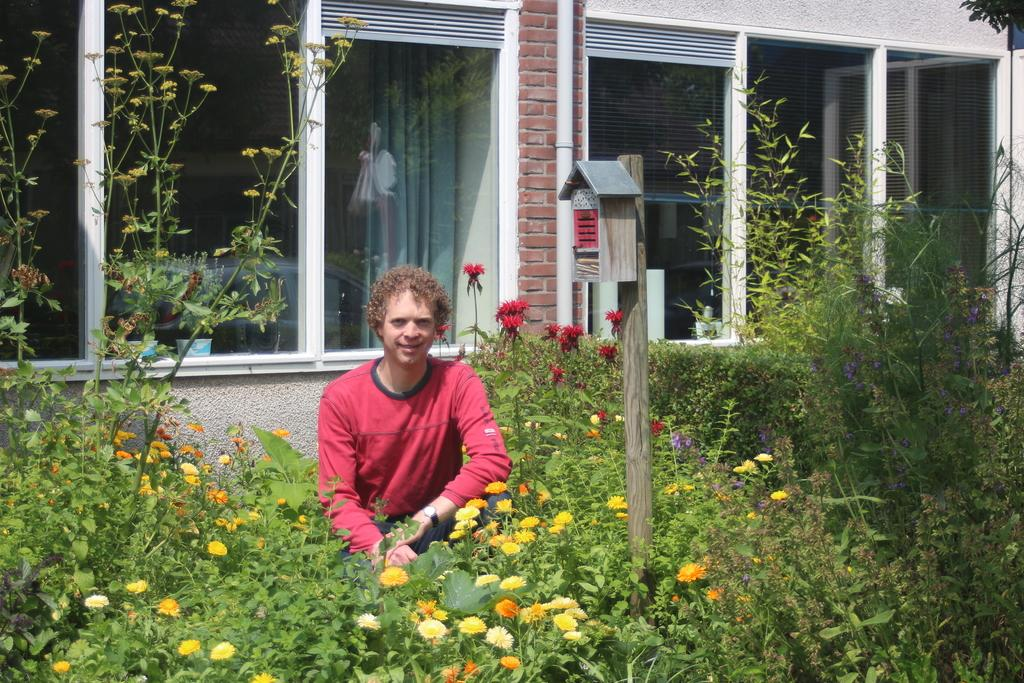What is the person in the image doing? There is a person smiling in the image. What type of vegetation can be seen in the image? There are plants and flowers in the image. Can you describe the structure in the image? There is a box on a wooden pole in the image. What can be seen in the background of the image? There is a wall, a pipe, glass windows, and a curtain visible through a window in the background of the image. What type of coat is the sponge wearing in the image? There is no sponge or coat present in the image. How does the person in the image believe in the image? The image does not convey any information about the person's beliefs. 